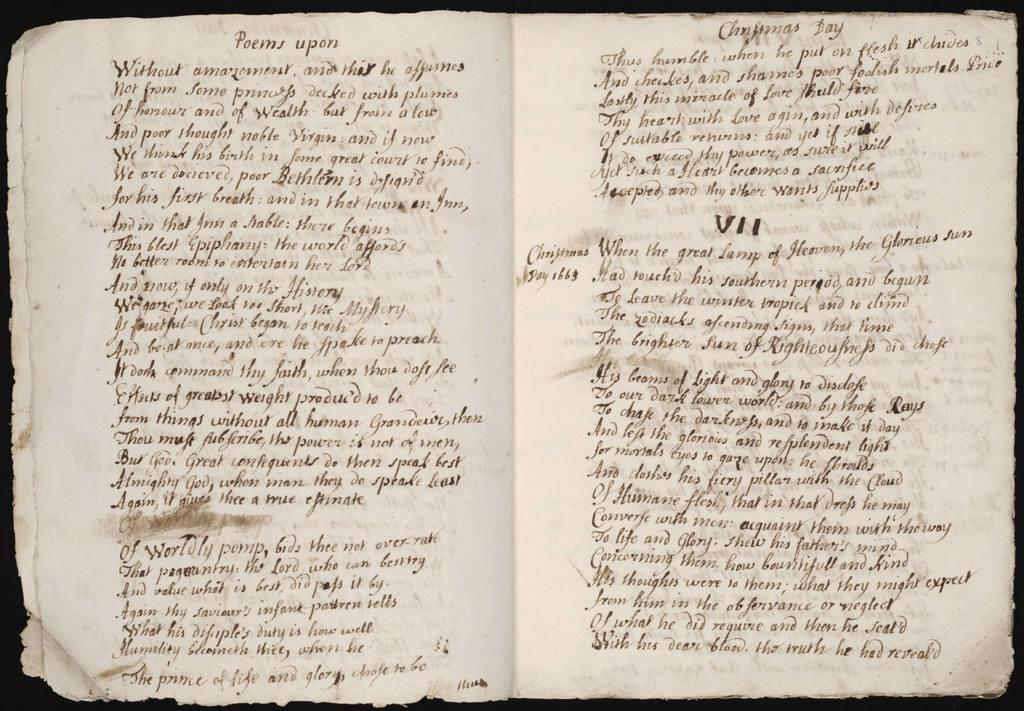<image>
Share a concise interpretation of the image provided. a handwritten book open to a page titled Poems upon 